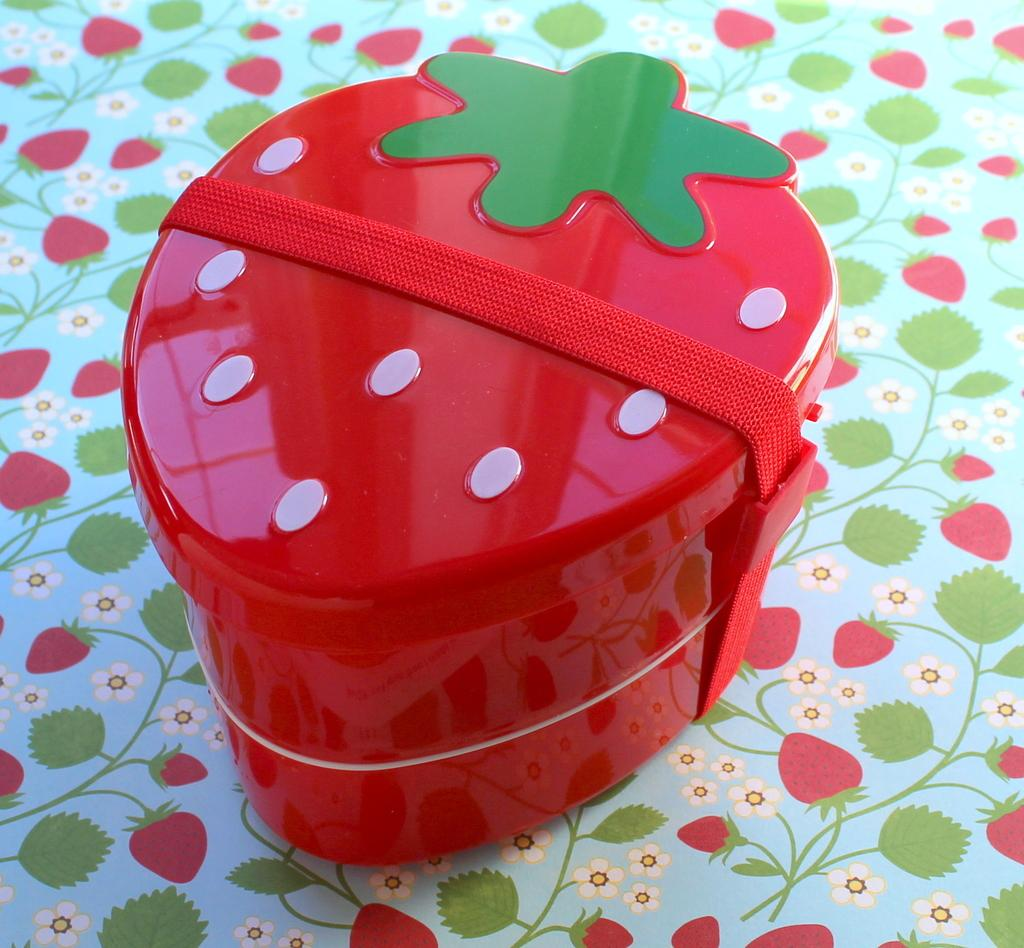What is the main object in the image? There is a tiffin box in the image. What is unique about the shape of the tiffin box? The tiffin box is shaped like a strawberry. Where is the tiffin box located in the image? The tiffin box is placed on a table. Can you see a kitten playing with a balloon near the sea in the image? There is no kitten, balloon, or sea present in the image; it only features a tiffin box shaped like a strawberry placed on a table. 